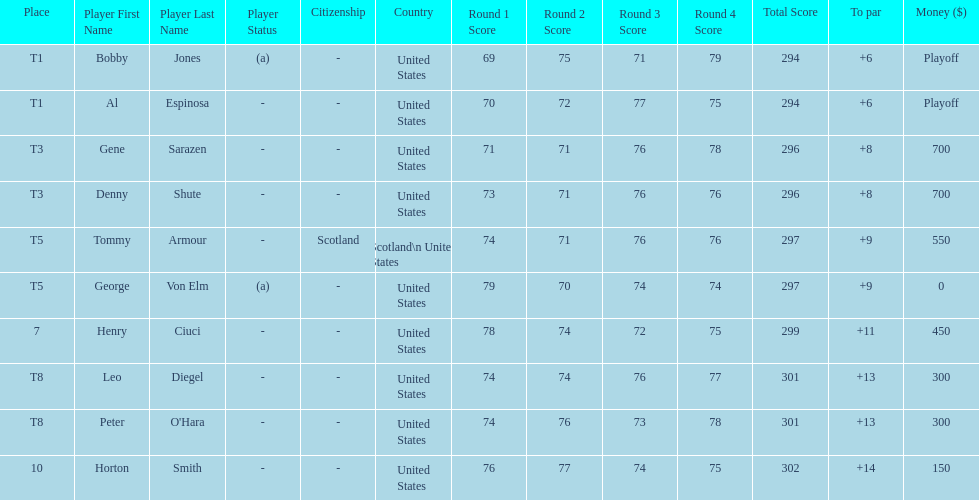Gene sarazen and denny shute are both from which country? United States. 